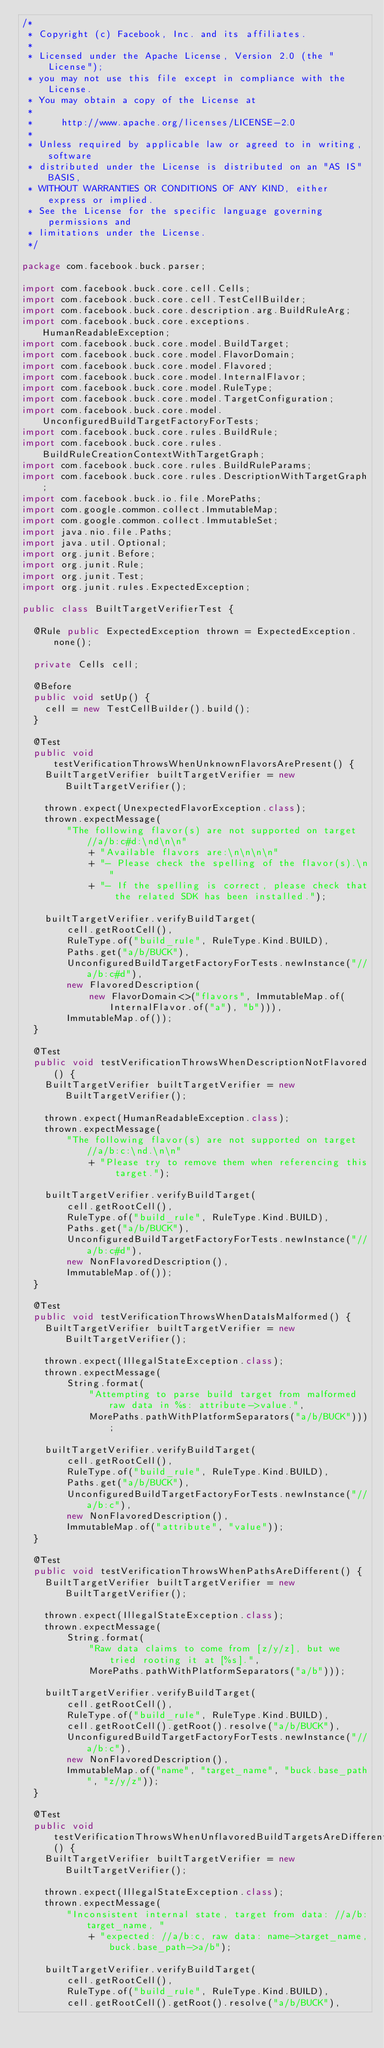Convert code to text. <code><loc_0><loc_0><loc_500><loc_500><_Java_>/*
 * Copyright (c) Facebook, Inc. and its affiliates.
 *
 * Licensed under the Apache License, Version 2.0 (the "License");
 * you may not use this file except in compliance with the License.
 * You may obtain a copy of the License at
 *
 *     http://www.apache.org/licenses/LICENSE-2.0
 *
 * Unless required by applicable law or agreed to in writing, software
 * distributed under the License is distributed on an "AS IS" BASIS,
 * WITHOUT WARRANTIES OR CONDITIONS OF ANY KIND, either express or implied.
 * See the License for the specific language governing permissions and
 * limitations under the License.
 */

package com.facebook.buck.parser;

import com.facebook.buck.core.cell.Cells;
import com.facebook.buck.core.cell.TestCellBuilder;
import com.facebook.buck.core.description.arg.BuildRuleArg;
import com.facebook.buck.core.exceptions.HumanReadableException;
import com.facebook.buck.core.model.BuildTarget;
import com.facebook.buck.core.model.FlavorDomain;
import com.facebook.buck.core.model.Flavored;
import com.facebook.buck.core.model.InternalFlavor;
import com.facebook.buck.core.model.RuleType;
import com.facebook.buck.core.model.TargetConfiguration;
import com.facebook.buck.core.model.UnconfiguredBuildTargetFactoryForTests;
import com.facebook.buck.core.rules.BuildRule;
import com.facebook.buck.core.rules.BuildRuleCreationContextWithTargetGraph;
import com.facebook.buck.core.rules.BuildRuleParams;
import com.facebook.buck.core.rules.DescriptionWithTargetGraph;
import com.facebook.buck.io.file.MorePaths;
import com.google.common.collect.ImmutableMap;
import com.google.common.collect.ImmutableSet;
import java.nio.file.Paths;
import java.util.Optional;
import org.junit.Before;
import org.junit.Rule;
import org.junit.Test;
import org.junit.rules.ExpectedException;

public class BuiltTargetVerifierTest {

  @Rule public ExpectedException thrown = ExpectedException.none();

  private Cells cell;

  @Before
  public void setUp() {
    cell = new TestCellBuilder().build();
  }

  @Test
  public void testVerificationThrowsWhenUnknownFlavorsArePresent() {
    BuiltTargetVerifier builtTargetVerifier = new BuiltTargetVerifier();

    thrown.expect(UnexpectedFlavorException.class);
    thrown.expectMessage(
        "The following flavor(s) are not supported on target //a/b:c#d:\nd\n\n"
            + "Available flavors are:\n\n\n\n"
            + "- Please check the spelling of the flavor(s).\n"
            + "- If the spelling is correct, please check that the related SDK has been installed.");

    builtTargetVerifier.verifyBuildTarget(
        cell.getRootCell(),
        RuleType.of("build_rule", RuleType.Kind.BUILD),
        Paths.get("a/b/BUCK"),
        UnconfiguredBuildTargetFactoryForTests.newInstance("//a/b:c#d"),
        new FlavoredDescription(
            new FlavorDomain<>("flavors", ImmutableMap.of(InternalFlavor.of("a"), "b"))),
        ImmutableMap.of());
  }

  @Test
  public void testVerificationThrowsWhenDescriptionNotFlavored() {
    BuiltTargetVerifier builtTargetVerifier = new BuiltTargetVerifier();

    thrown.expect(HumanReadableException.class);
    thrown.expectMessage(
        "The following flavor(s) are not supported on target //a/b:c:\nd.\n\n"
            + "Please try to remove them when referencing this target.");

    builtTargetVerifier.verifyBuildTarget(
        cell.getRootCell(),
        RuleType.of("build_rule", RuleType.Kind.BUILD),
        Paths.get("a/b/BUCK"),
        UnconfiguredBuildTargetFactoryForTests.newInstance("//a/b:c#d"),
        new NonFlavoredDescription(),
        ImmutableMap.of());
  }

  @Test
  public void testVerificationThrowsWhenDataIsMalformed() {
    BuiltTargetVerifier builtTargetVerifier = new BuiltTargetVerifier();

    thrown.expect(IllegalStateException.class);
    thrown.expectMessage(
        String.format(
            "Attempting to parse build target from malformed raw data in %s: attribute->value.",
            MorePaths.pathWithPlatformSeparators("a/b/BUCK")));

    builtTargetVerifier.verifyBuildTarget(
        cell.getRootCell(),
        RuleType.of("build_rule", RuleType.Kind.BUILD),
        Paths.get("a/b/BUCK"),
        UnconfiguredBuildTargetFactoryForTests.newInstance("//a/b:c"),
        new NonFlavoredDescription(),
        ImmutableMap.of("attribute", "value"));
  }

  @Test
  public void testVerificationThrowsWhenPathsAreDifferent() {
    BuiltTargetVerifier builtTargetVerifier = new BuiltTargetVerifier();

    thrown.expect(IllegalStateException.class);
    thrown.expectMessage(
        String.format(
            "Raw data claims to come from [z/y/z], but we tried rooting it at [%s].",
            MorePaths.pathWithPlatformSeparators("a/b")));

    builtTargetVerifier.verifyBuildTarget(
        cell.getRootCell(),
        RuleType.of("build_rule", RuleType.Kind.BUILD),
        cell.getRootCell().getRoot().resolve("a/b/BUCK"),
        UnconfiguredBuildTargetFactoryForTests.newInstance("//a/b:c"),
        new NonFlavoredDescription(),
        ImmutableMap.of("name", "target_name", "buck.base_path", "z/y/z"));
  }

  @Test
  public void testVerificationThrowsWhenUnflavoredBuildTargetsAreDifferent() {
    BuiltTargetVerifier builtTargetVerifier = new BuiltTargetVerifier();

    thrown.expect(IllegalStateException.class);
    thrown.expectMessage(
        "Inconsistent internal state, target from data: //a/b:target_name, "
            + "expected: //a/b:c, raw data: name->target_name,buck.base_path->a/b");

    builtTargetVerifier.verifyBuildTarget(
        cell.getRootCell(),
        RuleType.of("build_rule", RuleType.Kind.BUILD),
        cell.getRootCell().getRoot().resolve("a/b/BUCK"),</code> 